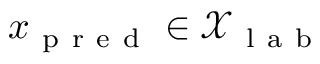Convert formula to latex. <formula><loc_0><loc_0><loc_500><loc_500>x _ { p r e d } \in \mathcal { X } _ { l a b }</formula> 